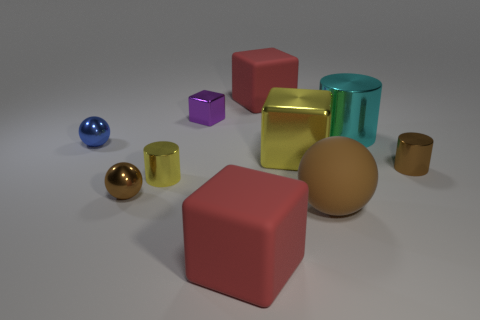Subtract 1 blocks. How many blocks are left? 3 Subtract all cubes. How many objects are left? 6 Subtract all blue spheres. Subtract all tiny purple metallic spheres. How many objects are left? 9 Add 2 metallic spheres. How many metallic spheres are left? 4 Add 10 blue metallic blocks. How many blue metallic blocks exist? 10 Subtract 0 red spheres. How many objects are left? 10 